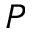<formula> <loc_0><loc_0><loc_500><loc_500>P</formula> 